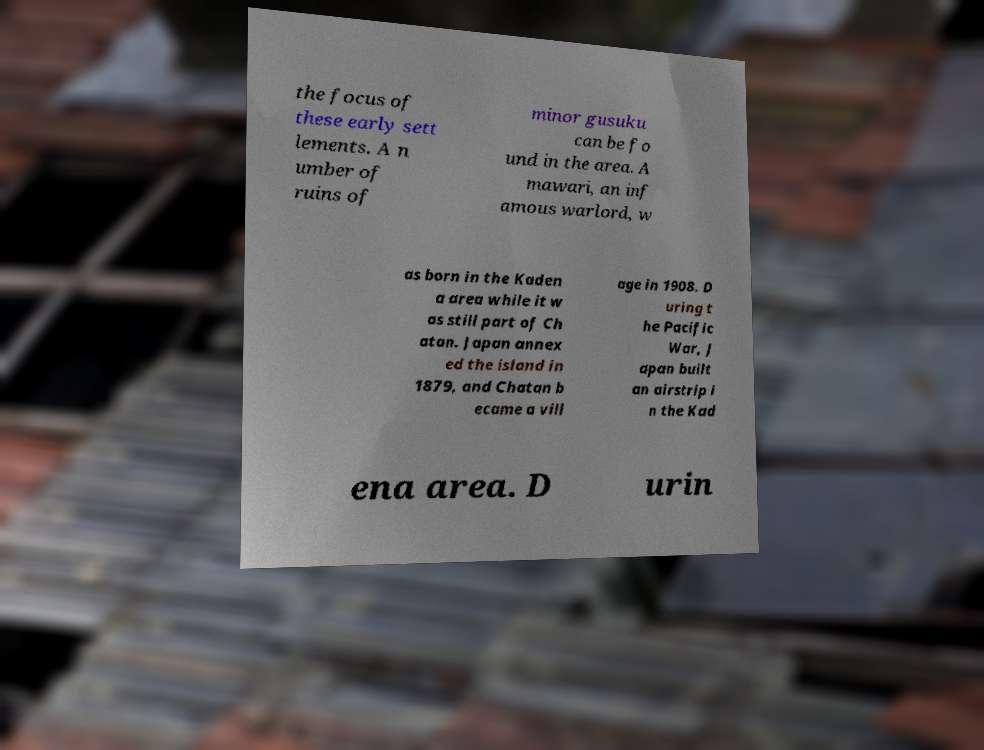For documentation purposes, I need the text within this image transcribed. Could you provide that? the focus of these early sett lements. A n umber of ruins of minor gusuku can be fo und in the area. A mawari, an inf amous warlord, w as born in the Kaden a area while it w as still part of Ch atan. Japan annex ed the island in 1879, and Chatan b ecame a vill age in 1908. D uring t he Pacific War, J apan built an airstrip i n the Kad ena area. D urin 